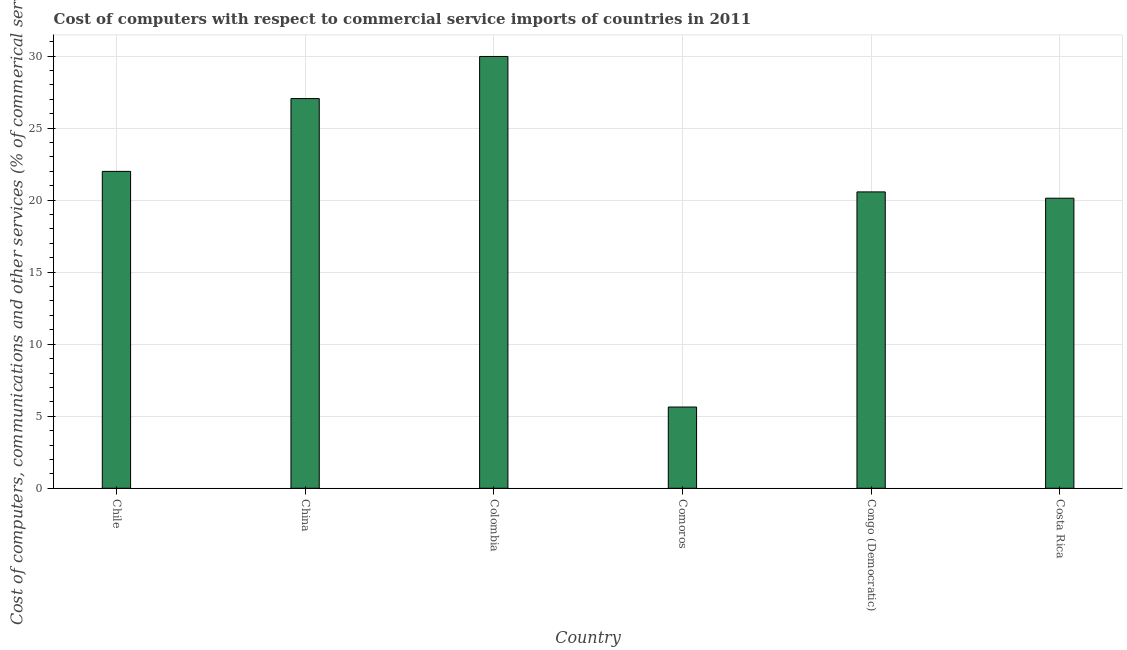Does the graph contain grids?
Provide a short and direct response. Yes. What is the title of the graph?
Keep it short and to the point. Cost of computers with respect to commercial service imports of countries in 2011. What is the label or title of the X-axis?
Provide a short and direct response. Country. What is the label or title of the Y-axis?
Provide a succinct answer. Cost of computers, communications and other services (% of commerical service exports). What is the  computer and other services in China?
Give a very brief answer. 27.05. Across all countries, what is the maximum  computer and other services?
Give a very brief answer. 29.97. Across all countries, what is the minimum  computer and other services?
Your answer should be compact. 5.64. In which country was the cost of communications minimum?
Ensure brevity in your answer.  Comoros. What is the sum of the cost of communications?
Offer a terse response. 125.35. What is the difference between the  computer and other services in Congo (Democratic) and Costa Rica?
Offer a terse response. 0.44. What is the average cost of communications per country?
Keep it short and to the point. 20.89. What is the median cost of communications?
Offer a very short reply. 21.28. In how many countries, is the cost of communications greater than 11 %?
Your answer should be compact. 5. What is the ratio of the cost of communications in China to that in Comoros?
Your answer should be compact. 4.8. Is the difference between the cost of communications in Comoros and Costa Rica greater than the difference between any two countries?
Ensure brevity in your answer.  No. What is the difference between the highest and the second highest  computer and other services?
Offer a terse response. 2.92. What is the difference between the highest and the lowest  computer and other services?
Offer a very short reply. 24.33. What is the Cost of computers, communications and other services (% of commerical service exports) in Chile?
Ensure brevity in your answer.  21.99. What is the Cost of computers, communications and other services (% of commerical service exports) of China?
Provide a short and direct response. 27.05. What is the Cost of computers, communications and other services (% of commerical service exports) of Colombia?
Provide a short and direct response. 29.97. What is the Cost of computers, communications and other services (% of commerical service exports) in Comoros?
Ensure brevity in your answer.  5.64. What is the Cost of computers, communications and other services (% of commerical service exports) of Congo (Democratic)?
Keep it short and to the point. 20.57. What is the Cost of computers, communications and other services (% of commerical service exports) of Costa Rica?
Provide a succinct answer. 20.13. What is the difference between the Cost of computers, communications and other services (% of commerical service exports) in Chile and China?
Make the answer very short. -5.05. What is the difference between the Cost of computers, communications and other services (% of commerical service exports) in Chile and Colombia?
Keep it short and to the point. -7.98. What is the difference between the Cost of computers, communications and other services (% of commerical service exports) in Chile and Comoros?
Your response must be concise. 16.35. What is the difference between the Cost of computers, communications and other services (% of commerical service exports) in Chile and Congo (Democratic)?
Offer a very short reply. 1.42. What is the difference between the Cost of computers, communications and other services (% of commerical service exports) in Chile and Costa Rica?
Keep it short and to the point. 1.86. What is the difference between the Cost of computers, communications and other services (% of commerical service exports) in China and Colombia?
Your answer should be very brief. -2.92. What is the difference between the Cost of computers, communications and other services (% of commerical service exports) in China and Comoros?
Your answer should be very brief. 21.41. What is the difference between the Cost of computers, communications and other services (% of commerical service exports) in China and Congo (Democratic)?
Keep it short and to the point. 6.48. What is the difference between the Cost of computers, communications and other services (% of commerical service exports) in China and Costa Rica?
Your answer should be compact. 6.92. What is the difference between the Cost of computers, communications and other services (% of commerical service exports) in Colombia and Comoros?
Give a very brief answer. 24.33. What is the difference between the Cost of computers, communications and other services (% of commerical service exports) in Colombia and Congo (Democratic)?
Provide a succinct answer. 9.4. What is the difference between the Cost of computers, communications and other services (% of commerical service exports) in Colombia and Costa Rica?
Your answer should be compact. 9.84. What is the difference between the Cost of computers, communications and other services (% of commerical service exports) in Comoros and Congo (Democratic)?
Provide a short and direct response. -14.93. What is the difference between the Cost of computers, communications and other services (% of commerical service exports) in Comoros and Costa Rica?
Offer a very short reply. -14.49. What is the difference between the Cost of computers, communications and other services (% of commerical service exports) in Congo (Democratic) and Costa Rica?
Give a very brief answer. 0.44. What is the ratio of the Cost of computers, communications and other services (% of commerical service exports) in Chile to that in China?
Make the answer very short. 0.81. What is the ratio of the Cost of computers, communications and other services (% of commerical service exports) in Chile to that in Colombia?
Ensure brevity in your answer.  0.73. What is the ratio of the Cost of computers, communications and other services (% of commerical service exports) in Chile to that in Congo (Democratic)?
Give a very brief answer. 1.07. What is the ratio of the Cost of computers, communications and other services (% of commerical service exports) in Chile to that in Costa Rica?
Offer a very short reply. 1.09. What is the ratio of the Cost of computers, communications and other services (% of commerical service exports) in China to that in Colombia?
Provide a short and direct response. 0.9. What is the ratio of the Cost of computers, communications and other services (% of commerical service exports) in China to that in Comoros?
Ensure brevity in your answer.  4.8. What is the ratio of the Cost of computers, communications and other services (% of commerical service exports) in China to that in Congo (Democratic)?
Make the answer very short. 1.31. What is the ratio of the Cost of computers, communications and other services (% of commerical service exports) in China to that in Costa Rica?
Make the answer very short. 1.34. What is the ratio of the Cost of computers, communications and other services (% of commerical service exports) in Colombia to that in Comoros?
Offer a terse response. 5.31. What is the ratio of the Cost of computers, communications and other services (% of commerical service exports) in Colombia to that in Congo (Democratic)?
Make the answer very short. 1.46. What is the ratio of the Cost of computers, communications and other services (% of commerical service exports) in Colombia to that in Costa Rica?
Offer a very short reply. 1.49. What is the ratio of the Cost of computers, communications and other services (% of commerical service exports) in Comoros to that in Congo (Democratic)?
Make the answer very short. 0.27. What is the ratio of the Cost of computers, communications and other services (% of commerical service exports) in Comoros to that in Costa Rica?
Provide a succinct answer. 0.28. What is the ratio of the Cost of computers, communications and other services (% of commerical service exports) in Congo (Democratic) to that in Costa Rica?
Provide a succinct answer. 1.02. 